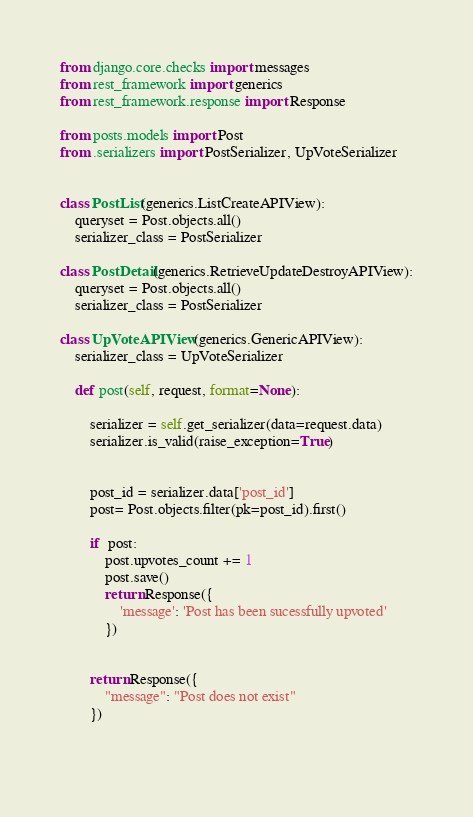Convert code to text. <code><loc_0><loc_0><loc_500><loc_500><_Python_>from django.core.checks import messages
from rest_framework import generics
from rest_framework.response import Response

from posts.models import Post
from .serializers import PostSerializer, UpVoteSerializer


class PostList(generics.ListCreateAPIView):
    queryset = Post.objects.all()
    serializer_class = PostSerializer

class PostDetail(generics.RetrieveUpdateDestroyAPIView):
    queryset = Post.objects.all()
    serializer_class = PostSerializer

class UpVoteAPIView(generics.GenericAPIView):
    serializer_class = UpVoteSerializer

    def post(self, request, format=None):

        serializer = self.get_serializer(data=request.data)
        serializer.is_valid(raise_exception=True)


        post_id = serializer.data['post_id']
        post= Post.objects.filter(pk=post_id).first()

        if  post:
            post.upvotes_count += 1
            post.save()
            return Response({
                'message': 'Post has been sucessfully upvoted'
            })


        return Response({
            "message": "Post does not exist"
        })

        </code> 